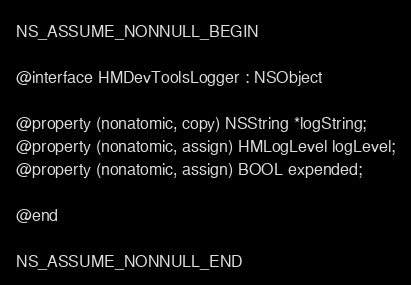Convert code to text. <code><loc_0><loc_0><loc_500><loc_500><_C_>
NS_ASSUME_NONNULL_BEGIN

@interface HMDevToolsLogger : NSObject

@property (nonatomic, copy) NSString *logString;
@property (nonatomic, assign) HMLogLevel logLevel;
@property (nonatomic, assign) BOOL expended;

@end

NS_ASSUME_NONNULL_END
</code> 